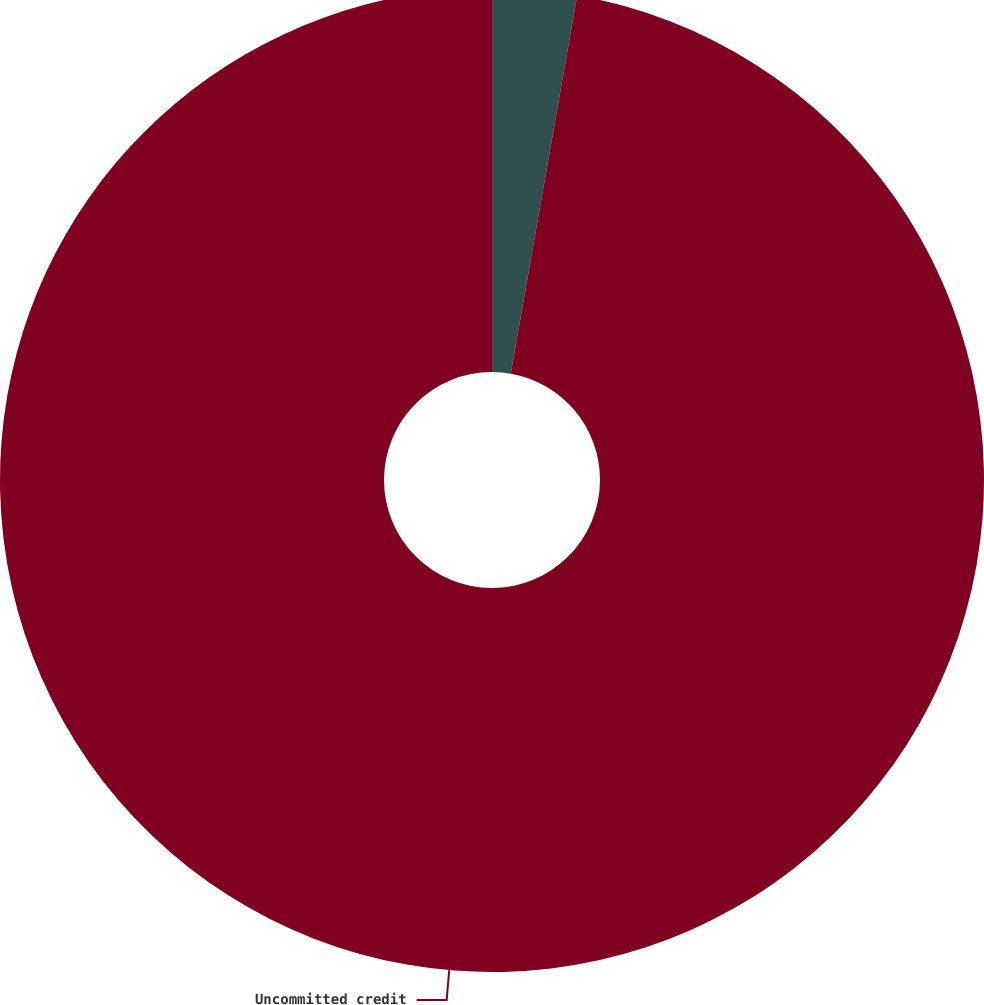Convert chart. <chart><loc_0><loc_0><loc_500><loc_500><pie_chart><fcel>Committed credit agreement<fcel>Uncommitted credit<nl><fcel>2.77%<fcel>97.23%<nl></chart> 